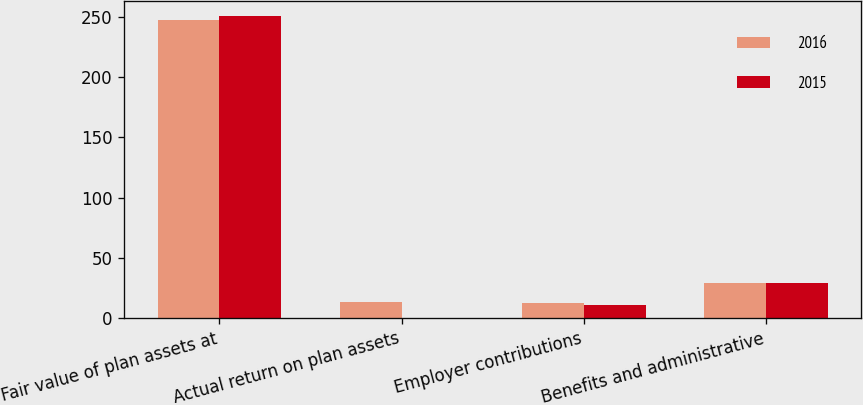Convert chart to OTSL. <chart><loc_0><loc_0><loc_500><loc_500><stacked_bar_chart><ecel><fcel>Fair value of plan assets at<fcel>Actual return on plan assets<fcel>Employer contributions<fcel>Benefits and administrative<nl><fcel>2016<fcel>247.5<fcel>13.6<fcel>12.4<fcel>29.1<nl><fcel>2015<fcel>250.6<fcel>0.3<fcel>10.9<fcel>29.1<nl></chart> 